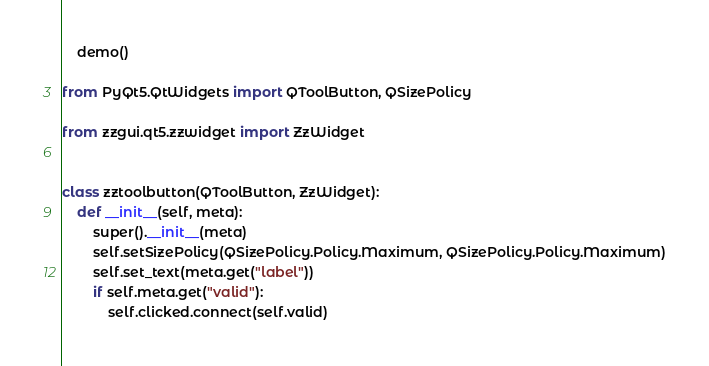Convert code to text. <code><loc_0><loc_0><loc_500><loc_500><_Python_>
    demo()

from PyQt5.QtWidgets import QToolButton, QSizePolicy

from zzgui.qt5.zzwidget import ZzWidget


class zztoolbutton(QToolButton, ZzWidget):
    def __init__(self, meta):
        super().__init__(meta)
        self.setSizePolicy(QSizePolicy.Policy.Maximum, QSizePolicy.Policy.Maximum)
        self.set_text(meta.get("label"))
        if self.meta.get("valid"):
            self.clicked.connect(self.valid)
</code> 